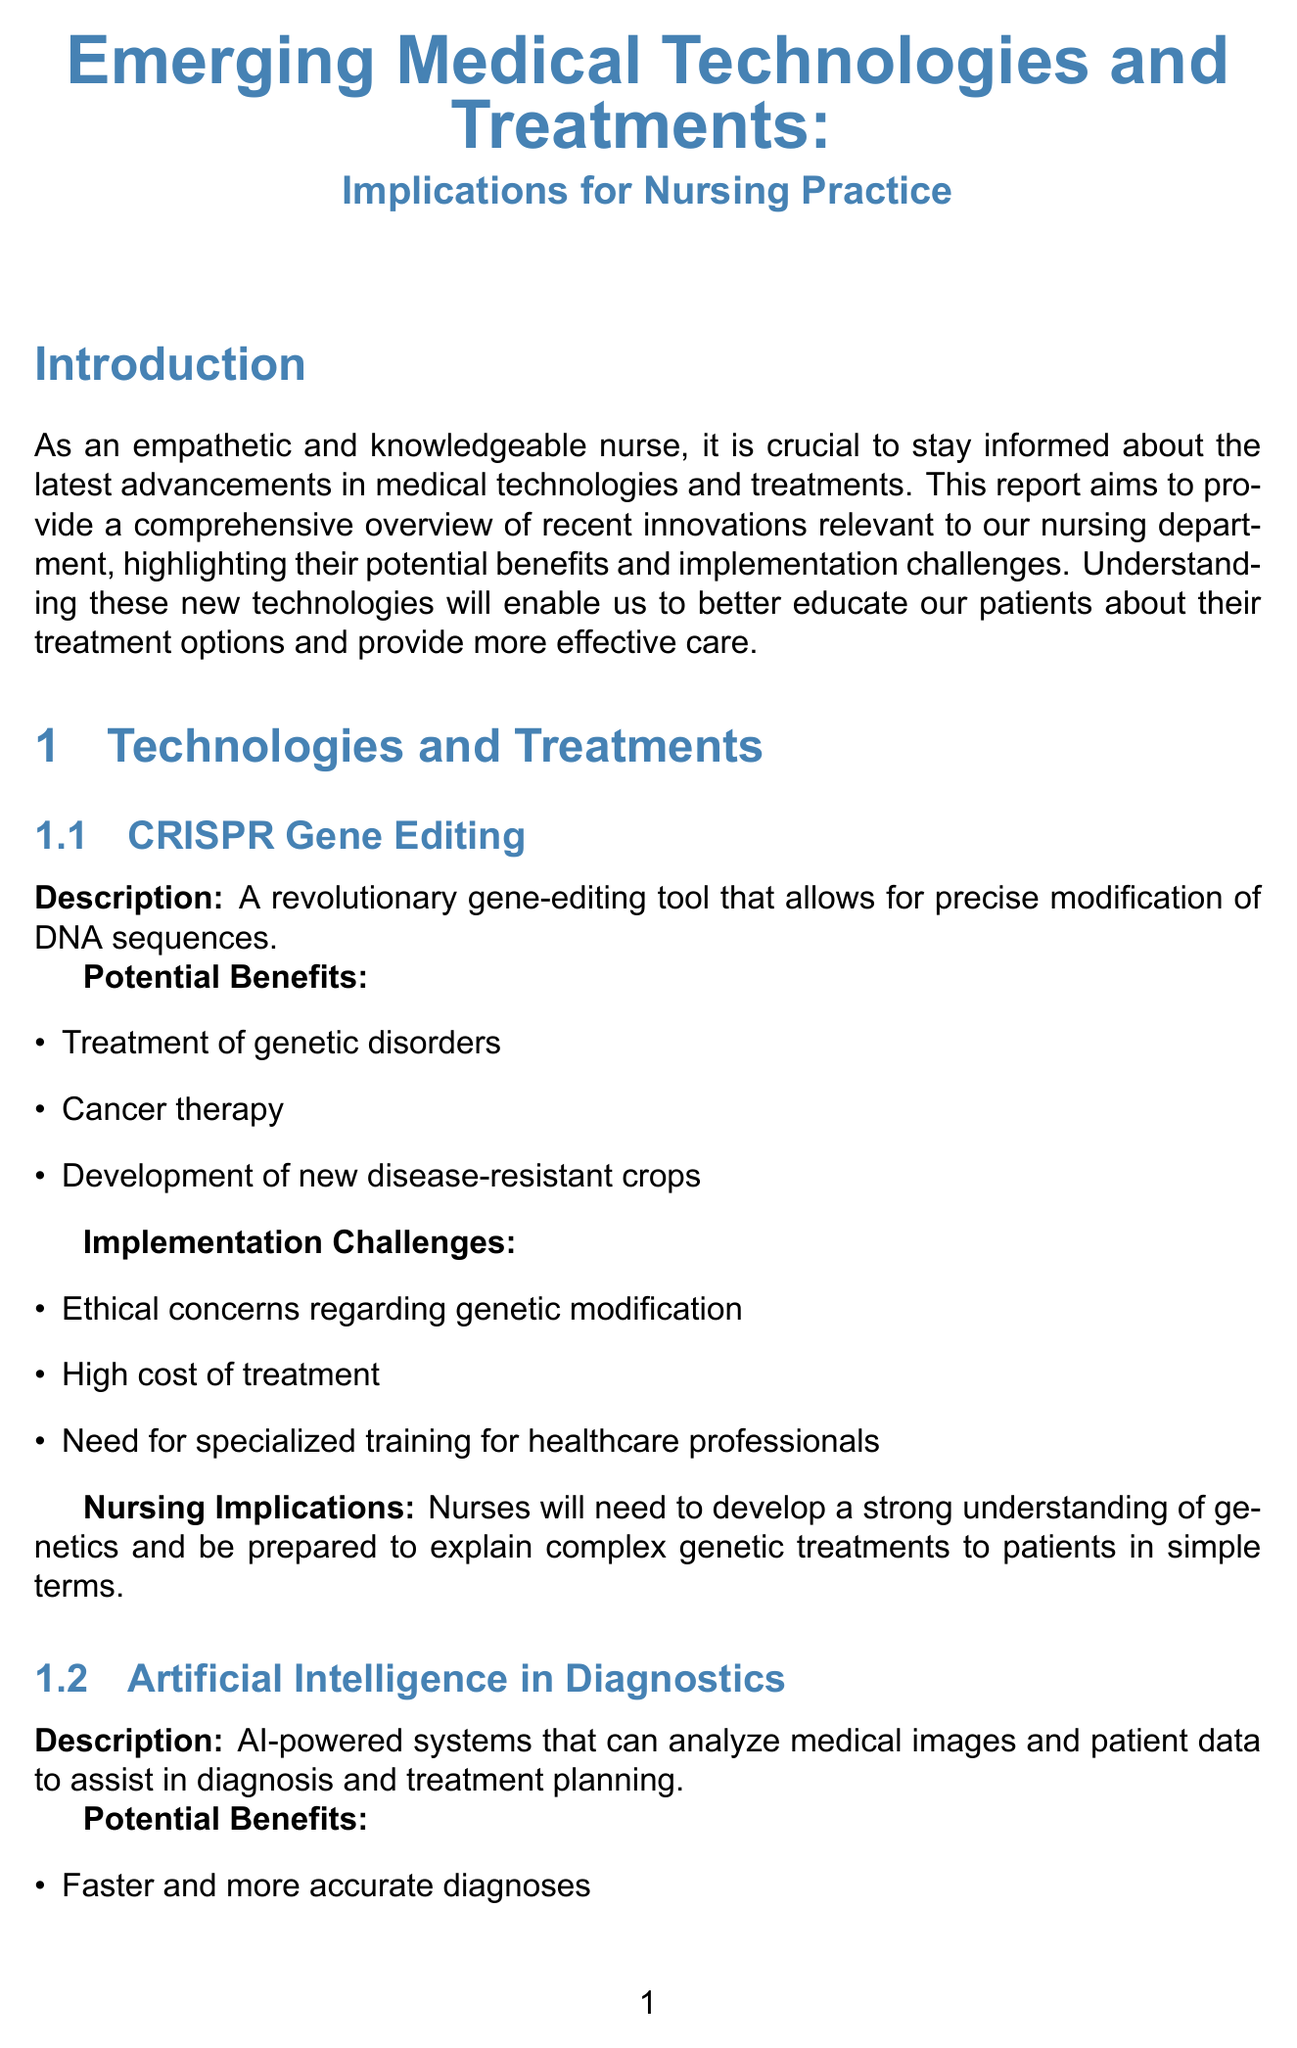what is the title of the report? The title of the report is explicitly mentioned at the beginning, which summarizes the core topic being discussed.
Answer: Emerging Medical Technologies and Treatments: Implications for Nursing Practice name one potential benefit of CRISPR gene editing. The report lists several potential benefits for each technology, including for CRISPR gene editing.
Answer: Treatment of genetic disorders what is one implementation challenge of Artificial Intelligence in Diagnostics? The report identifies specific challenges for each technology, one of which pertains to AI in Diagnostics.
Answer: Data privacy and security concerns which nursing implication is associated with Immunotherapy? The report outlines specific nursing implications for each treatment, particularly for Immunotherapy.
Answer: Nurses will need to closely monitor patients for immune-related side effects how many implementation strategies are mentioned in the report? The document presents a specific number of strategies aimed at implementing new technologies and treatments.
Answer: Three what is the main importance of understanding new technologies for nurses? The report emphasizes a key reason for nurses to stay informed about advancements in medical technologies.
Answer: Provide more effective care name one benefit of Continuous Education Programs. Each implementation strategy has associated benefits outlined in the report.
Answer: Improves patient care and outcomes what is a potential benefit of 3D Bioprinting? The report specifies various benefits related to 3D Bioprinting technology.
Answer: Customized implants and prosthetics 